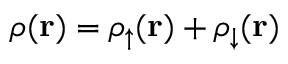<formula> <loc_0><loc_0><loc_500><loc_500>\rho ( { r } ) = \rho _ { \uparrow } ( { r } ) + \rho _ { \downarrow } ( { r } )</formula> 